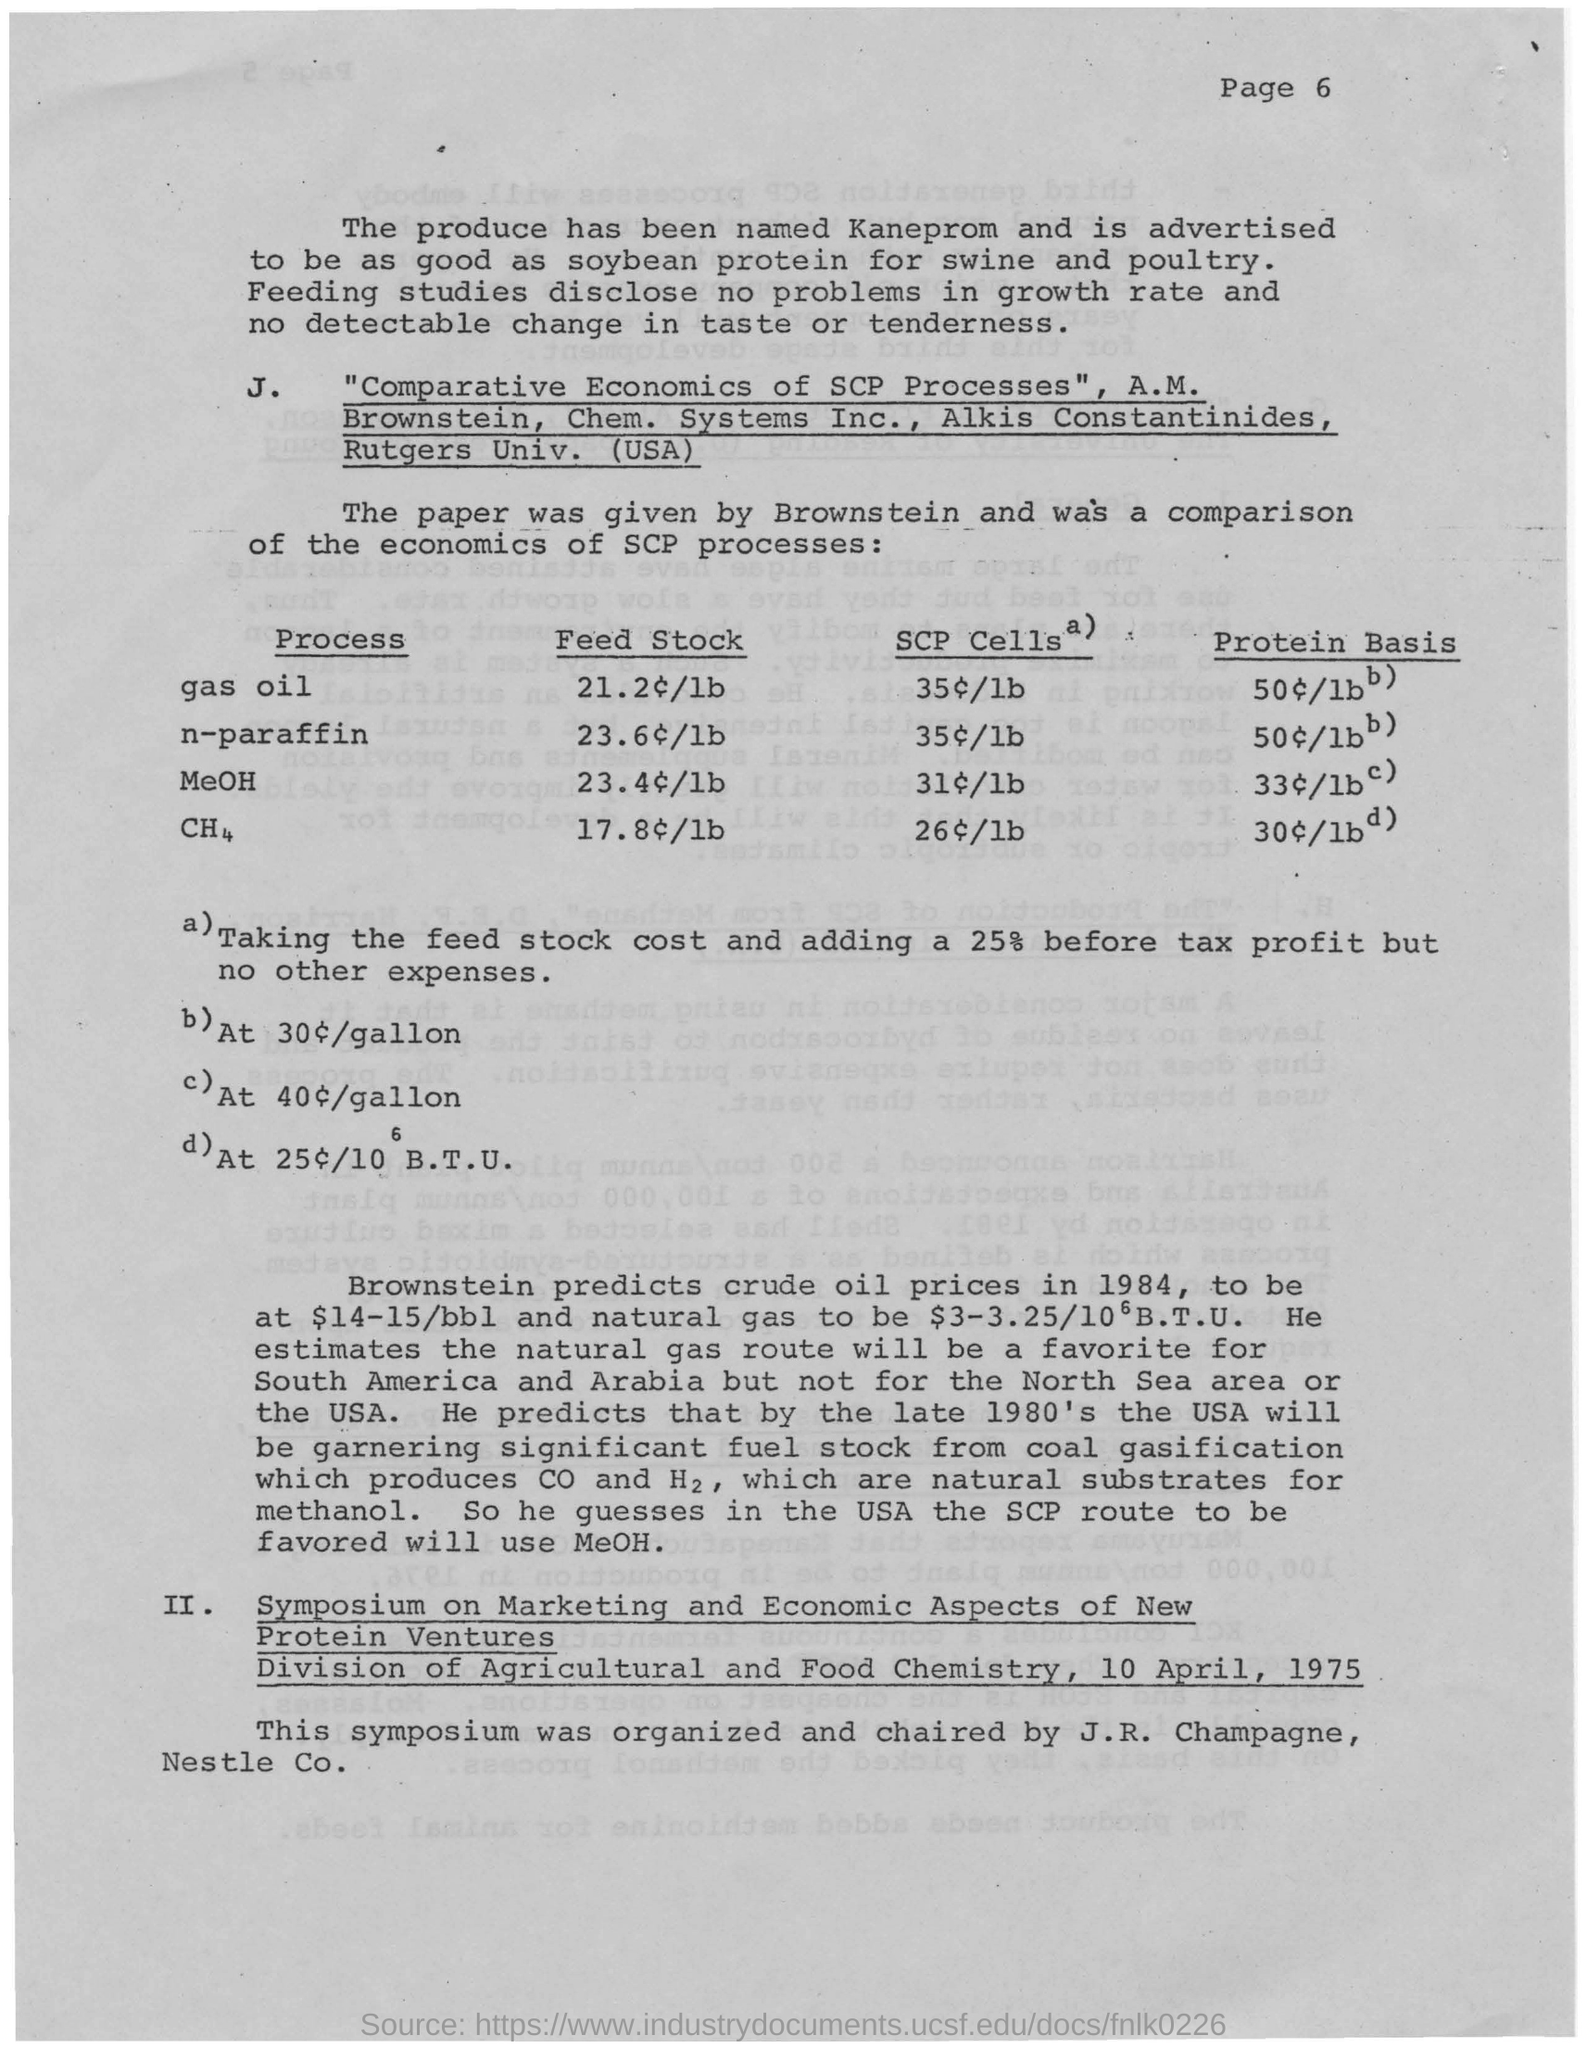Mention a couple of crucial points in this snapshot. Brownstein predicted that the price of crude oil in 1984 would be between $14 and $15 per barrel. The symposium was organized and chaired by J.R. Champagne. The paper titled 'Comparative Economics of SCP Processes' by A.M. Brownstein, Chem. Systems Inc., and Alkis Constantinides, Rutgers Univ. (USA) is named. The symposium organized by the Division of Agricultural and Food Chemistry is the Symposium on Marketing and Economic Aspects of New Protein Ventures. The produce has been named Kaneprom. 